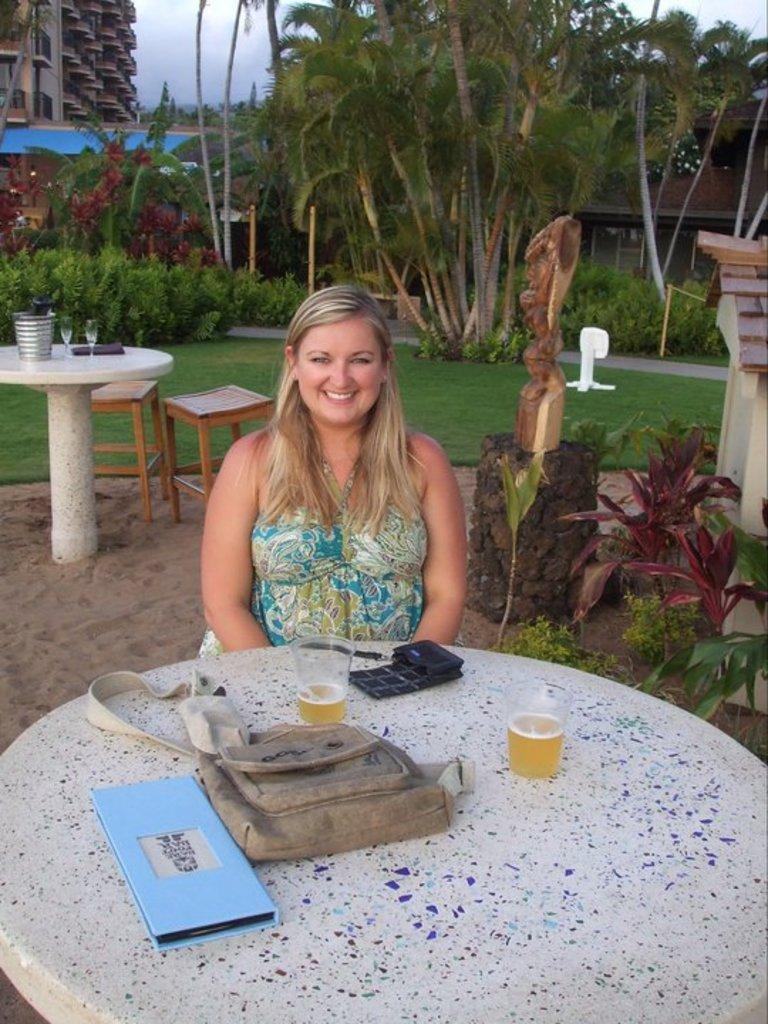Could you give a brief overview of what you see in this image? In the middle a woman is sitting on the chair in front of the table on which file, bag, glass and so on kept. In the background trees are visible and a grass visible and plants are visible. In the top left building is visible and a sky blue in color is visible. This image is taken during day time in a lawn area. 